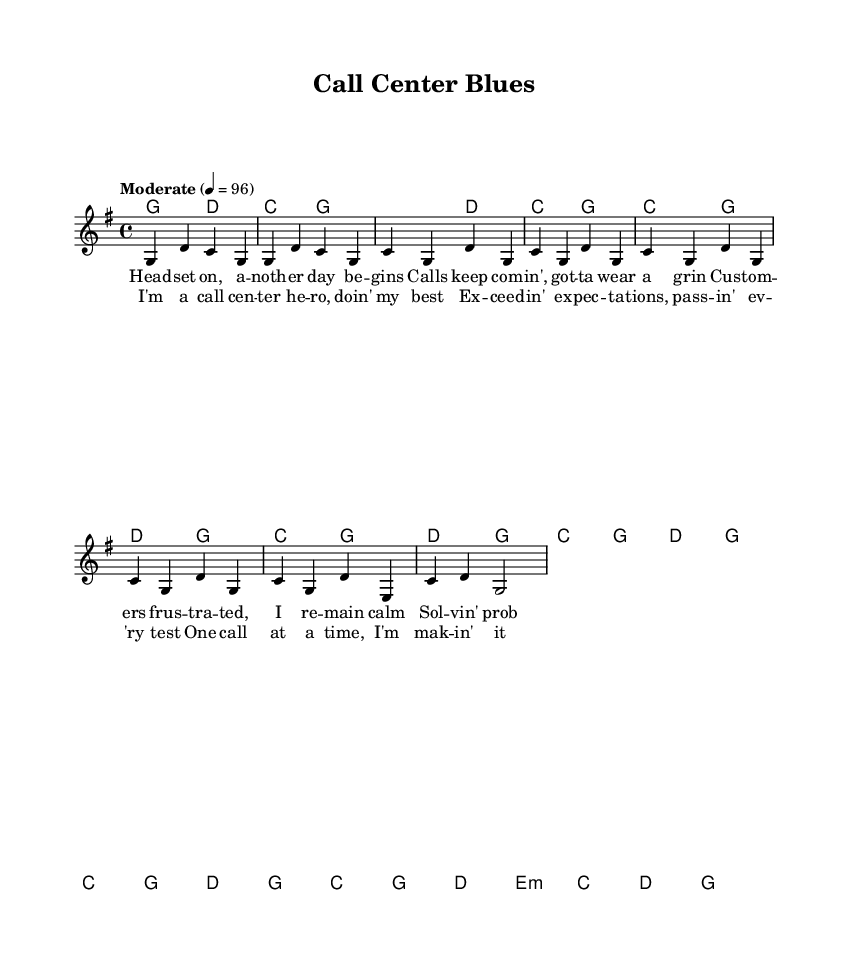What is the key signature of this music? The key signature is G major, which has one sharp (F#). This can be identified at the beginning of the sheet music, where the key signature is indicated.
Answer: G major What is the time signature of this music? The time signature is 4/4, which is indicated at the beginning of the staff. This means there are four beats in a measure, and the quarter note gets one beat.
Answer: 4/4 What is the tempo marking for this piece? The tempo marking is set to "Moderate" with a tempo of 96 beats per minute. This is indicated at the beginning of the melody, directing the performer to play at this moderate pace.
Answer: Moderate 96 How many measures are in the verse? The verse consists of 8 measures as counted through the music staff notation in the verse section. Each set of notes corresponds to one measure, and there are eight groupings of notes before the chorus starts.
Answer: 8 measures How does the chorus differ musically from the verse? The chorus features a different melody pattern with chord changes mostly centered around C and G, giving it a more uplifting feel, while the verse alternates between the chords G, D, and C. This contrast is a typical characteristic in country music to emphasize the emotional content of the lyrics.
Answer: Different melody and chords What is the lyrical theme of this music? The lyrical theme focuses on overcoming daily challenges in a call center environment, reflecting resilience and positivity despite frustrations. The lyrics speak about being a "call center hero" and dealing with customers calmly, which encapsulates the daily struggles and triumphs.
Answer: Overcoming daily challenges What does the phrase "overcoming challenges" represent in the country music context? In country music, "overcoming challenges" often represents perseverance, strength, and the ability to face life's difficulties with a hopeful attitude, which resonates deeply with listeners. This theme is prevalent in many classic country tunes, often reflecting real-life experiences of struggle and triumph.
Answer: Perseverance and strength 